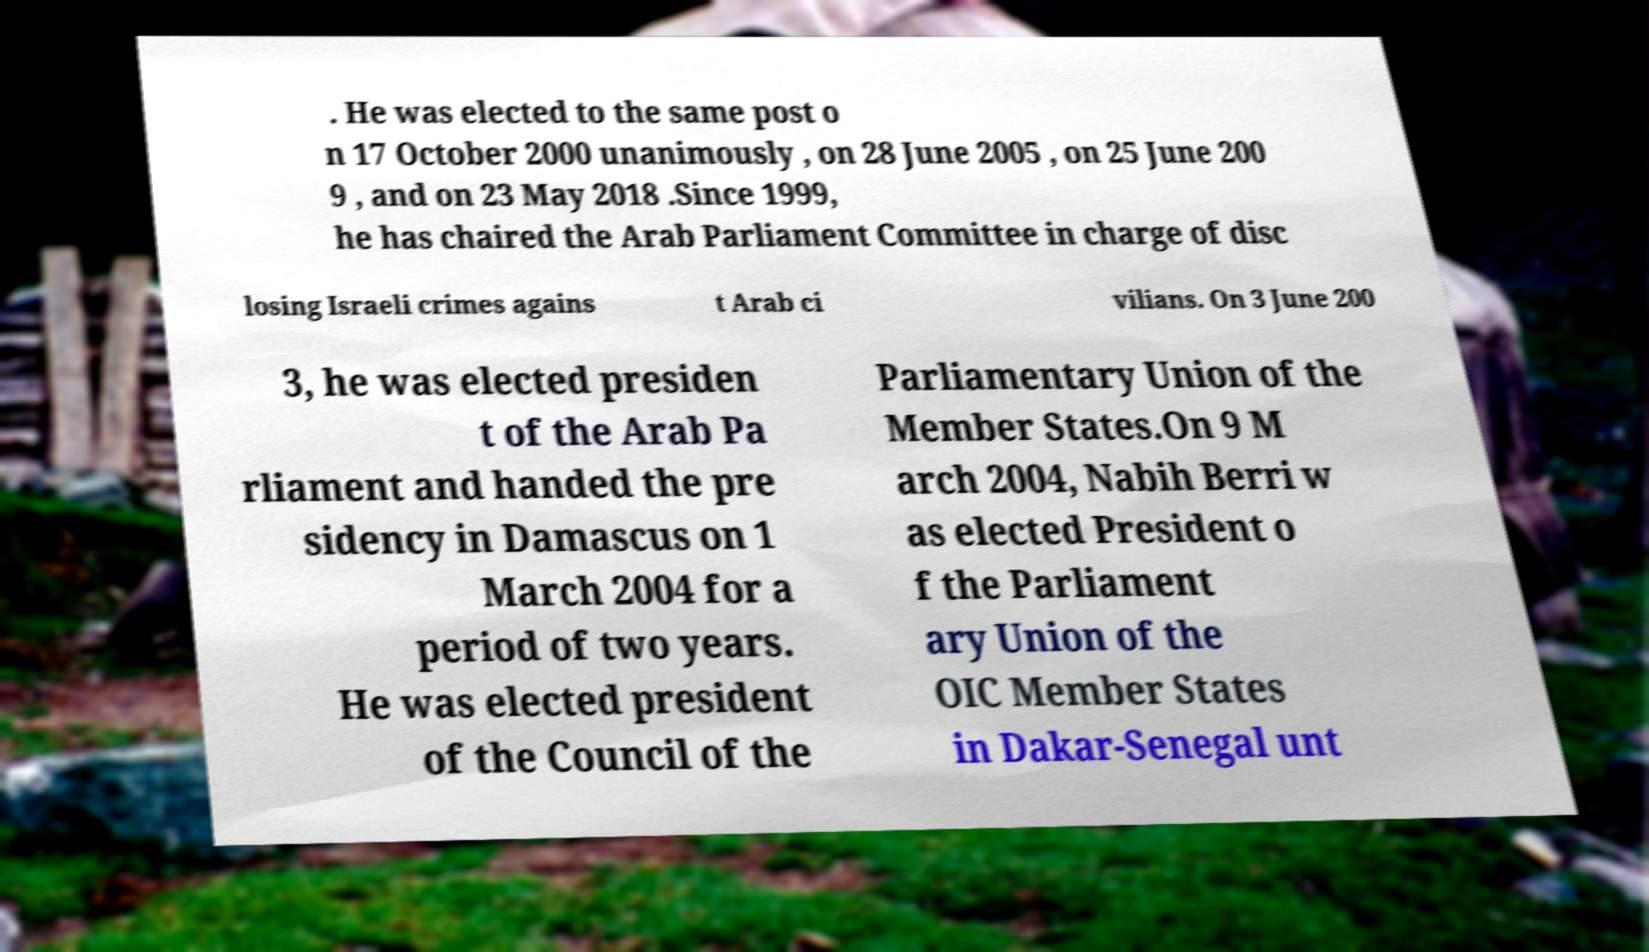For documentation purposes, I need the text within this image transcribed. Could you provide that? . He was elected to the same post o n 17 October 2000 unanimously , on 28 June 2005 , on 25 June 200 9 , and on 23 May 2018 .Since 1999, he has chaired the Arab Parliament Committee in charge of disc losing Israeli crimes agains t Arab ci vilians. On 3 June 200 3, he was elected presiden t of the Arab Pa rliament and handed the pre sidency in Damascus on 1 March 2004 for a period of two years. He was elected president of the Council of the Parliamentary Union of the Member States.On 9 M arch 2004, Nabih Berri w as elected President o f the Parliament ary Union of the OIC Member States in Dakar-Senegal unt 